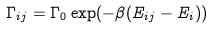<formula> <loc_0><loc_0><loc_500><loc_500>\Gamma _ { i j } = \Gamma _ { 0 } \exp ( - \beta ( E _ { i j } - E _ { i } ) )</formula> 